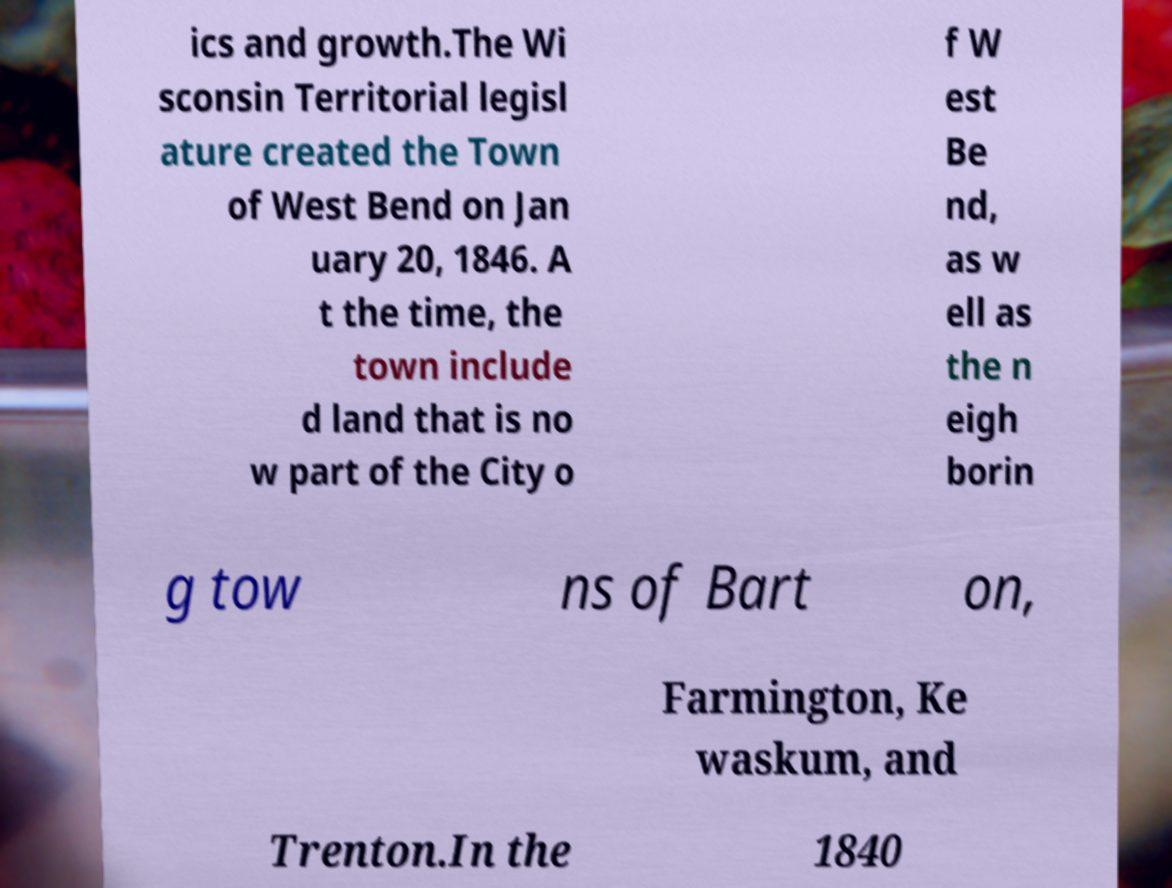Please identify and transcribe the text found in this image. ics and growth.The Wi sconsin Territorial legisl ature created the Town of West Bend on Jan uary 20, 1846. A t the time, the town include d land that is no w part of the City o f W est Be nd, as w ell as the n eigh borin g tow ns of Bart on, Farmington, Ke waskum, and Trenton.In the 1840 